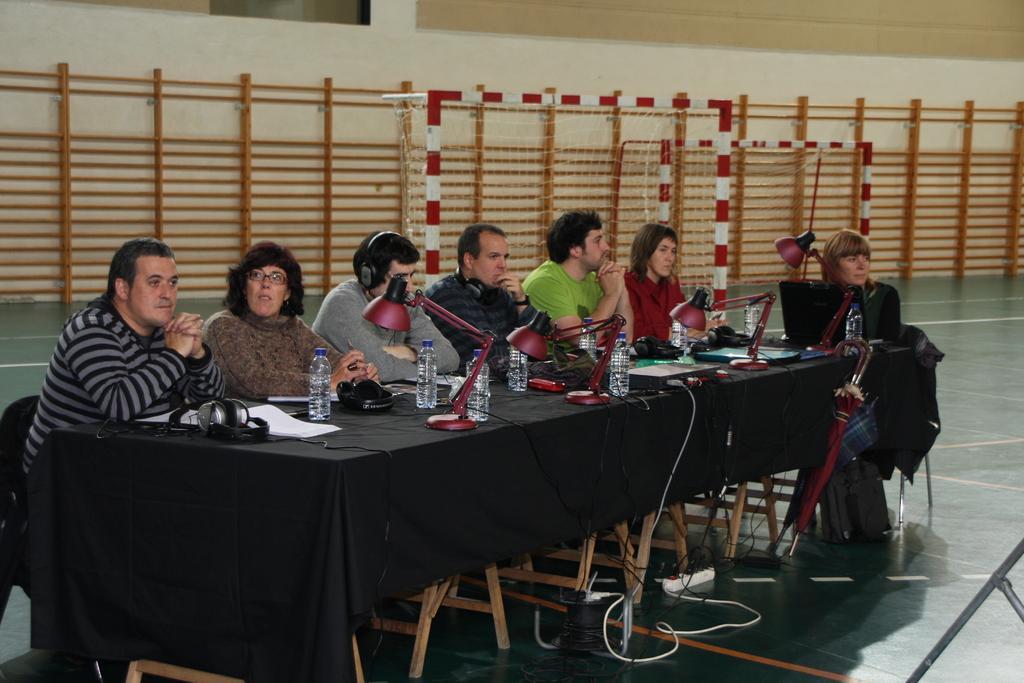Describe this image in one or two sentences. In this image I can see the group of people sitting in front of the table. On the table there are water bottles,lights and the headset. 